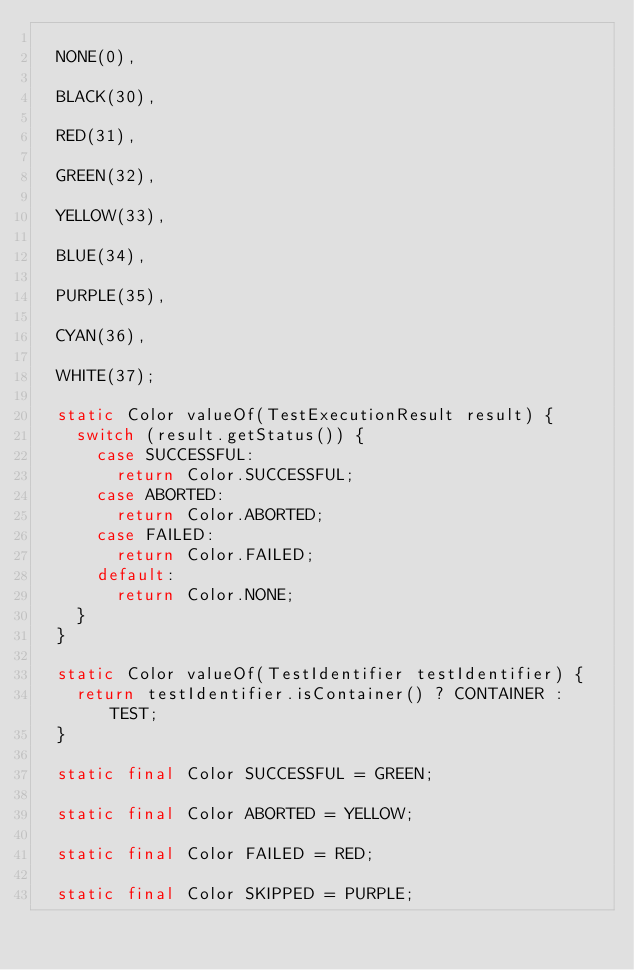<code> <loc_0><loc_0><loc_500><loc_500><_Java_>
	NONE(0),

	BLACK(30),

	RED(31),

	GREEN(32),

	YELLOW(33),

	BLUE(34),

	PURPLE(35),

	CYAN(36),

	WHITE(37);

	static Color valueOf(TestExecutionResult result) {
		switch (result.getStatus()) {
			case SUCCESSFUL:
				return Color.SUCCESSFUL;
			case ABORTED:
				return Color.ABORTED;
			case FAILED:
				return Color.FAILED;
			default:
				return Color.NONE;
		}
	}

	static Color valueOf(TestIdentifier testIdentifier) {
		return testIdentifier.isContainer() ? CONTAINER : TEST;
	}

	static final Color SUCCESSFUL = GREEN;

	static final Color ABORTED = YELLOW;

	static final Color FAILED = RED;

	static final Color SKIPPED = PURPLE;
</code> 